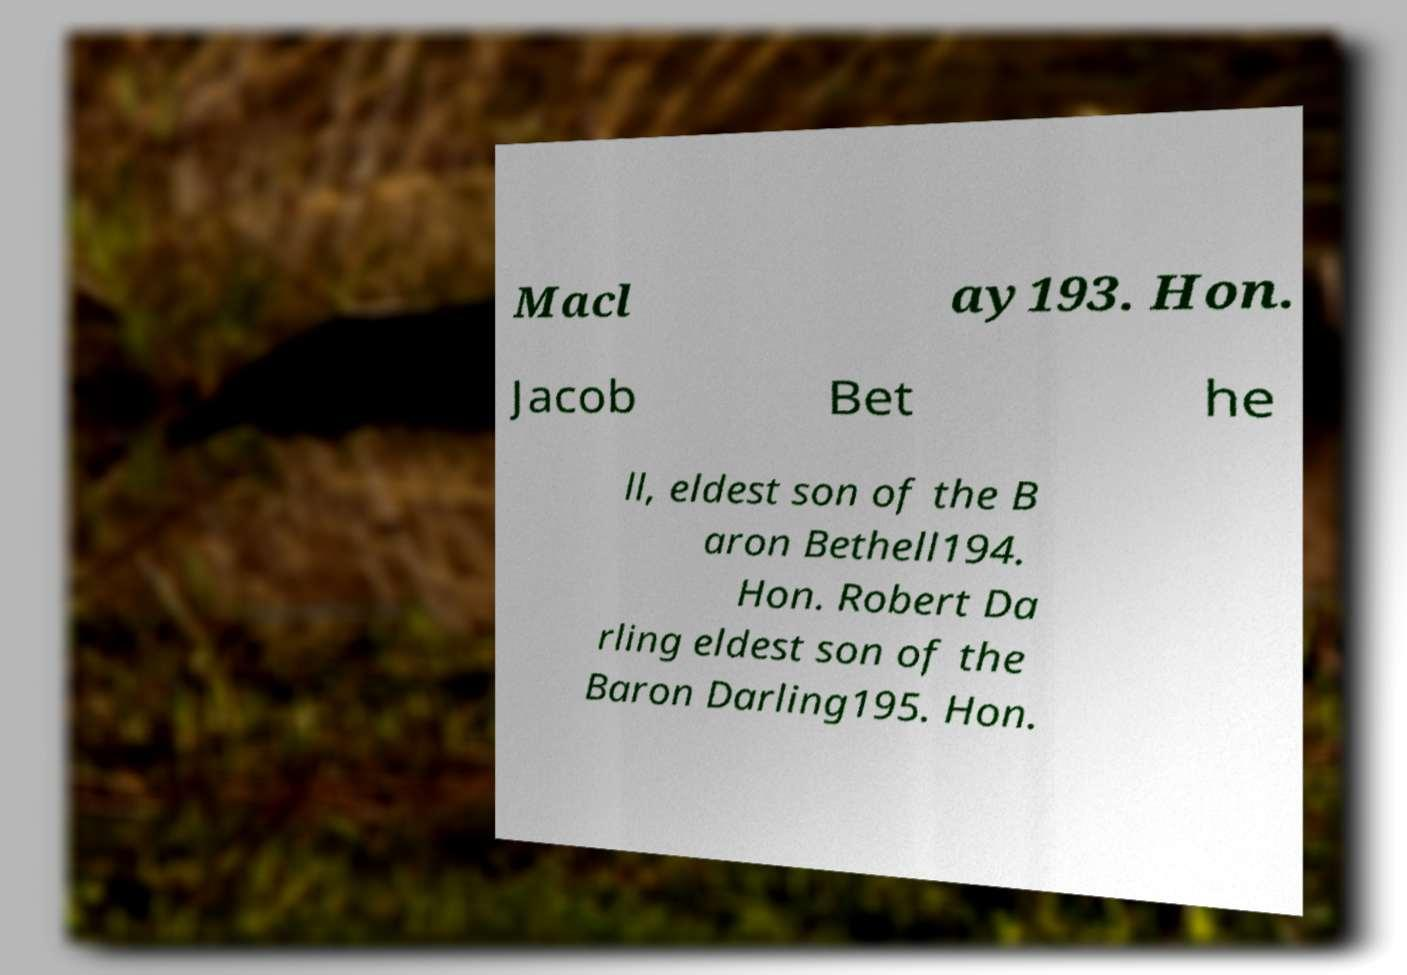I need the written content from this picture converted into text. Can you do that? Macl ay193. Hon. Jacob Bet he ll, eldest son of the B aron Bethell194. Hon. Robert Da rling eldest son of the Baron Darling195. Hon. 